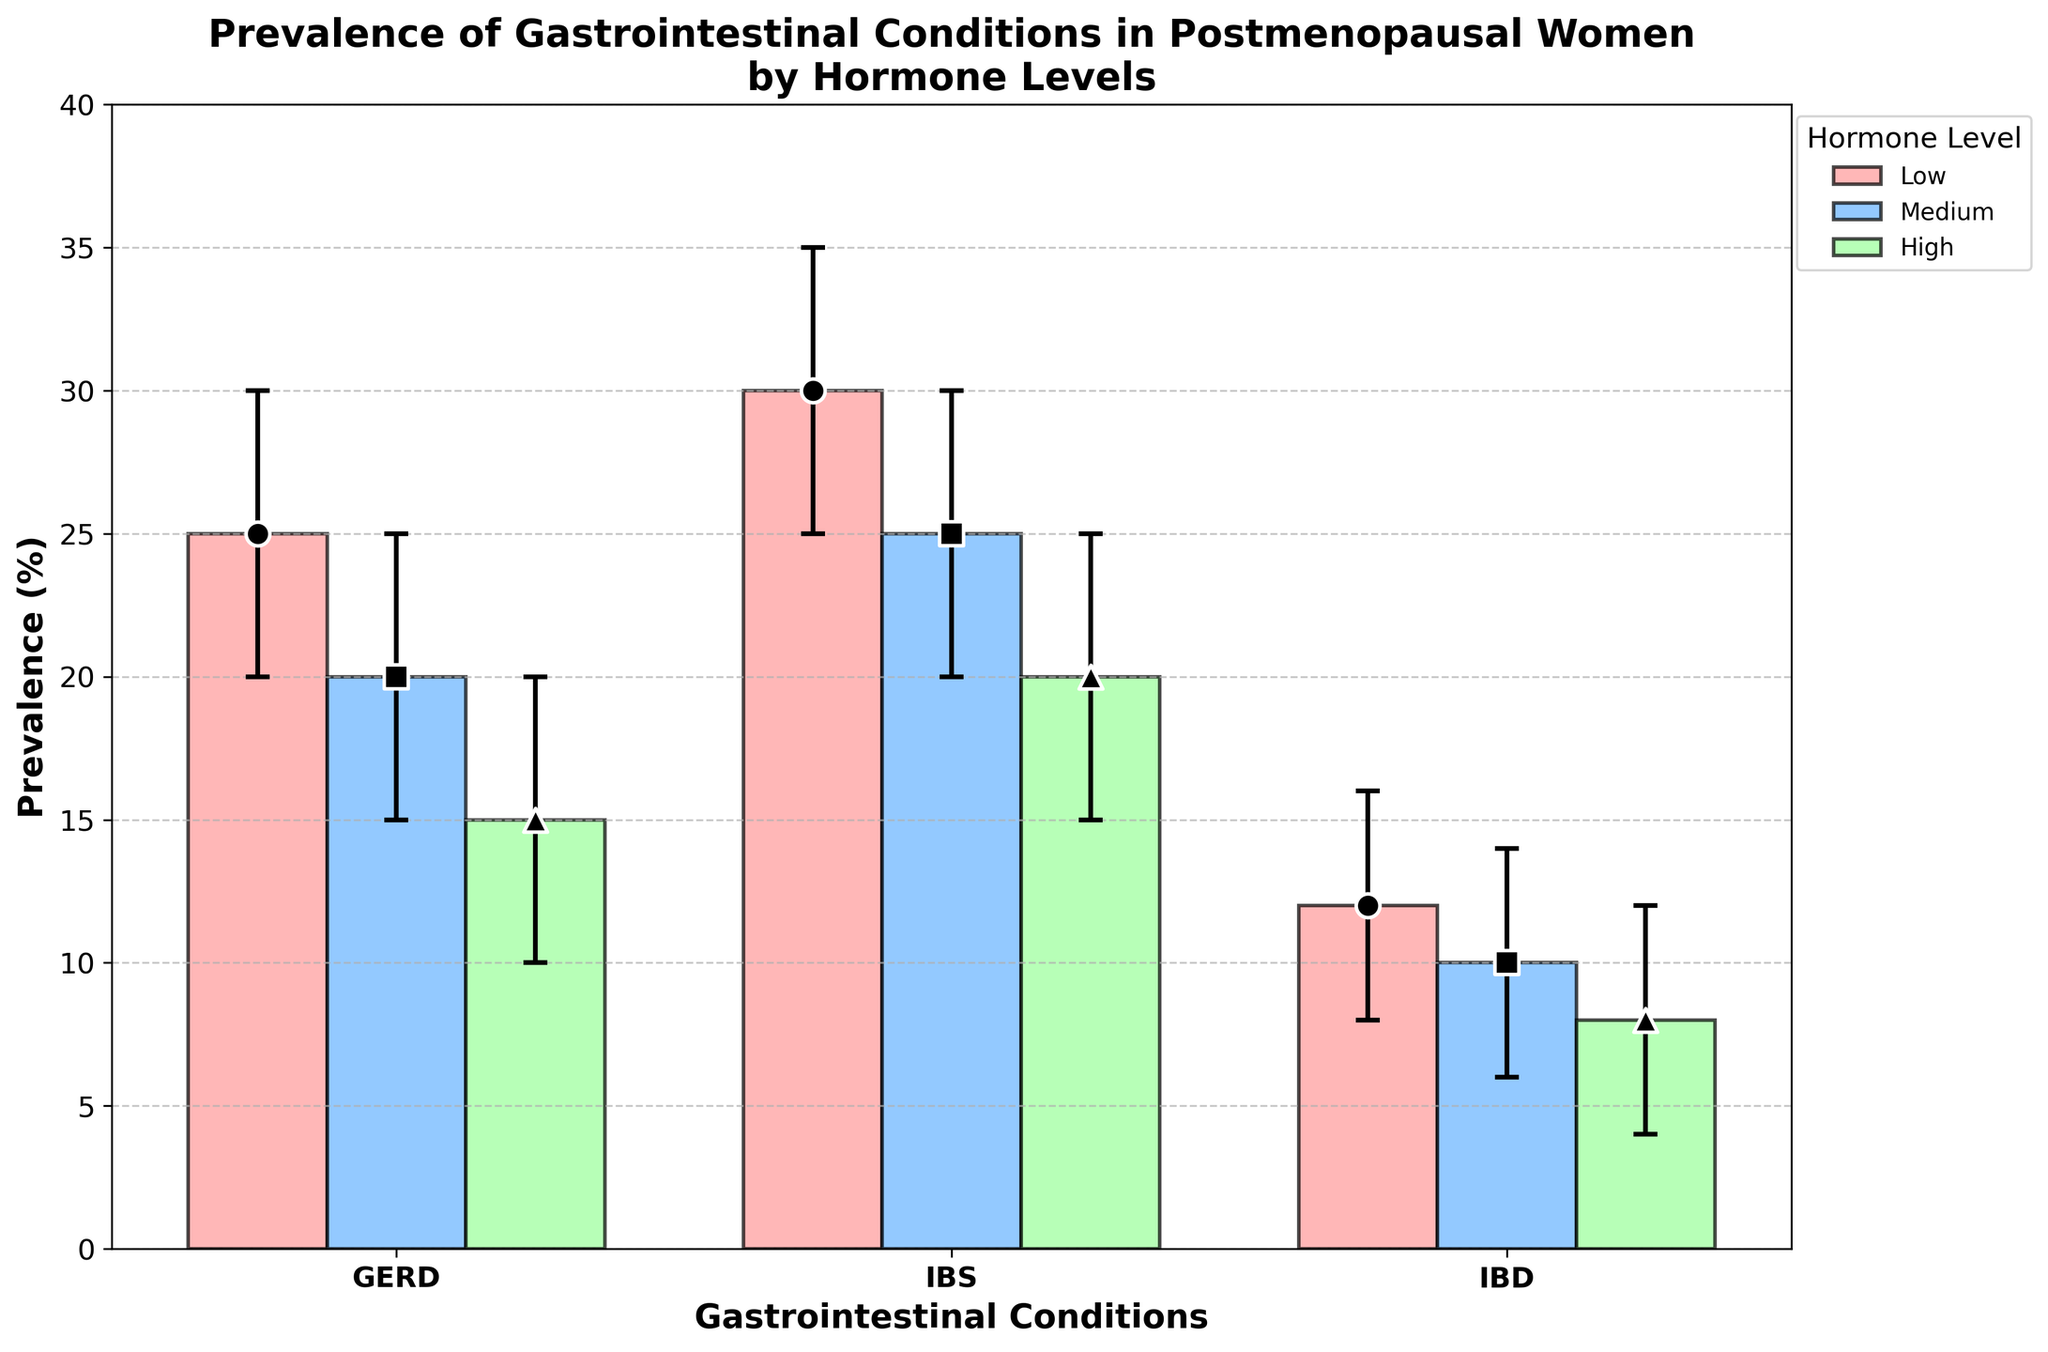What is the title of the figure? The title of the figure is generally located at the top-center of the plot and describes the main information being visualized. In this case, the title describes the prevalence of gastrointestinal conditions in postmenopausal women by hormone levels.
Answer: Prevalence of Gastrointestinal Conditions in Postmenopausal Women by Hormone Levels What are the three gastrointestinal conditions shown in the plot? The labels on the x-axis indicate the specific gastrointestinal conditions being analyzed. There are three clearly shown conditions in the plot.
Answer: GERD, IBS, IBD How does the prevalence of IBS in postmenopausal women change with hormone levels? By looking at the bar heights and the error bars for the condition labeled "IBS," we can observe the depicted prevalence values for each hormone level (Low, Medium, and High).
Answer: It decreases from 30% (Low) to 25% (Medium) to 20% (High) Which hormone level group has the highest prevalence of GERD, and what is that prevalence? By comparing the heights of the bars within the GERD category, the bar corresponding to the highest value indicates the group with the highest prevalence.
Answer: Low, 25% What is the confidence interval for the prevalence of IBD among postmenopausal women with low hormone levels? The confidence intervals are shown by the vertical lines (error bars) extending from the top of each bar. For the IBD condition at the Low hormone level, reading the error bars gives the lower and upper bounds.
Answer: 8% to 16% Compare the difference in prevalence of GERD between low and high hormone levels. To find the difference, subtract the prevalence value for the high hormone level from the value for the low hormone level within the GERD condition.
Answer: 10% What is the overall trend in the prevalence of gastrointestinal conditions among postmenopausal women as hormone levels increase? Observing the bar heights for each condition's hormone level group will reveal whether prevalence values increase, decrease, or remain stable with ascending hormone levels.
Answer: Decreasing trend Which hormone level shows the least variability in the prevalence of IBS? Variability can be assessed by the length of the error bars; the shortest error bar in the IBS condition represents the least variability.
Answer: High What is the average prevalence of IBD across all hormone levels? To calculate the average, sum the prevalence percentages of IBD for Low, Medium, and High hormone levels and divide by the number of hormone levels (3).
Answer: (12 + 10 + 8)/3 = 10% Does any gastrointestinal condition have overlapping confidence intervals between hormone levels? If so, which condition(s)? By inspecting the error bars for each hormone level within each condition, if error bars (confidence intervals) overlap, it indicates that the ranges are not significantly different.
Answer: Yes, GERD and IBS 